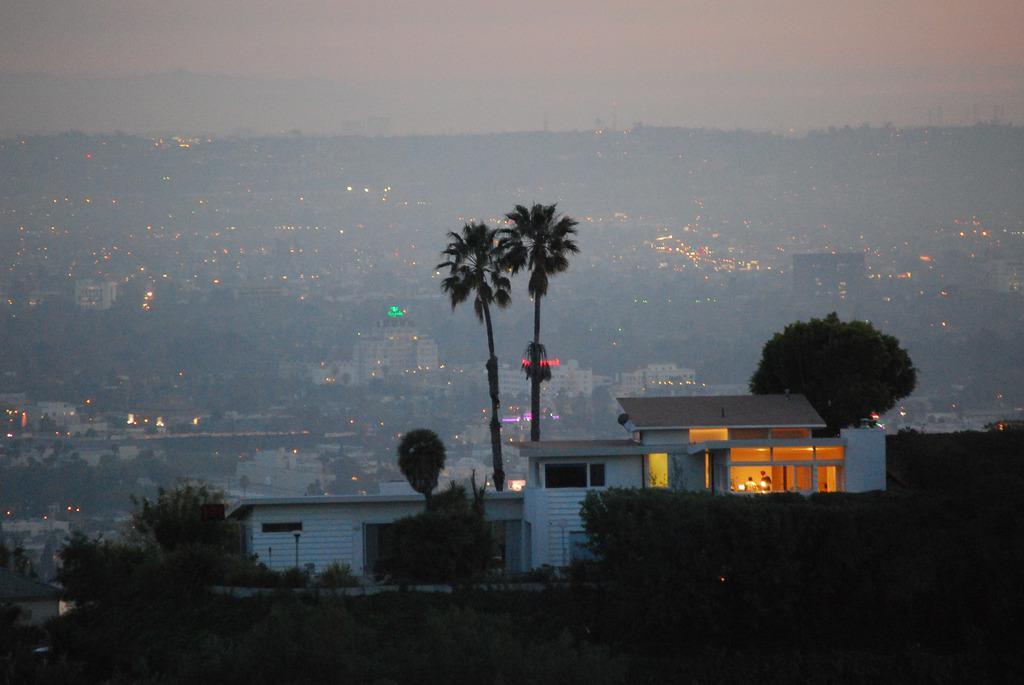Describe this image in one or two sentences. At the bottom of the image there is a shed and we can see trees. In the background there are buildings, trees, lights, hills and sky. 